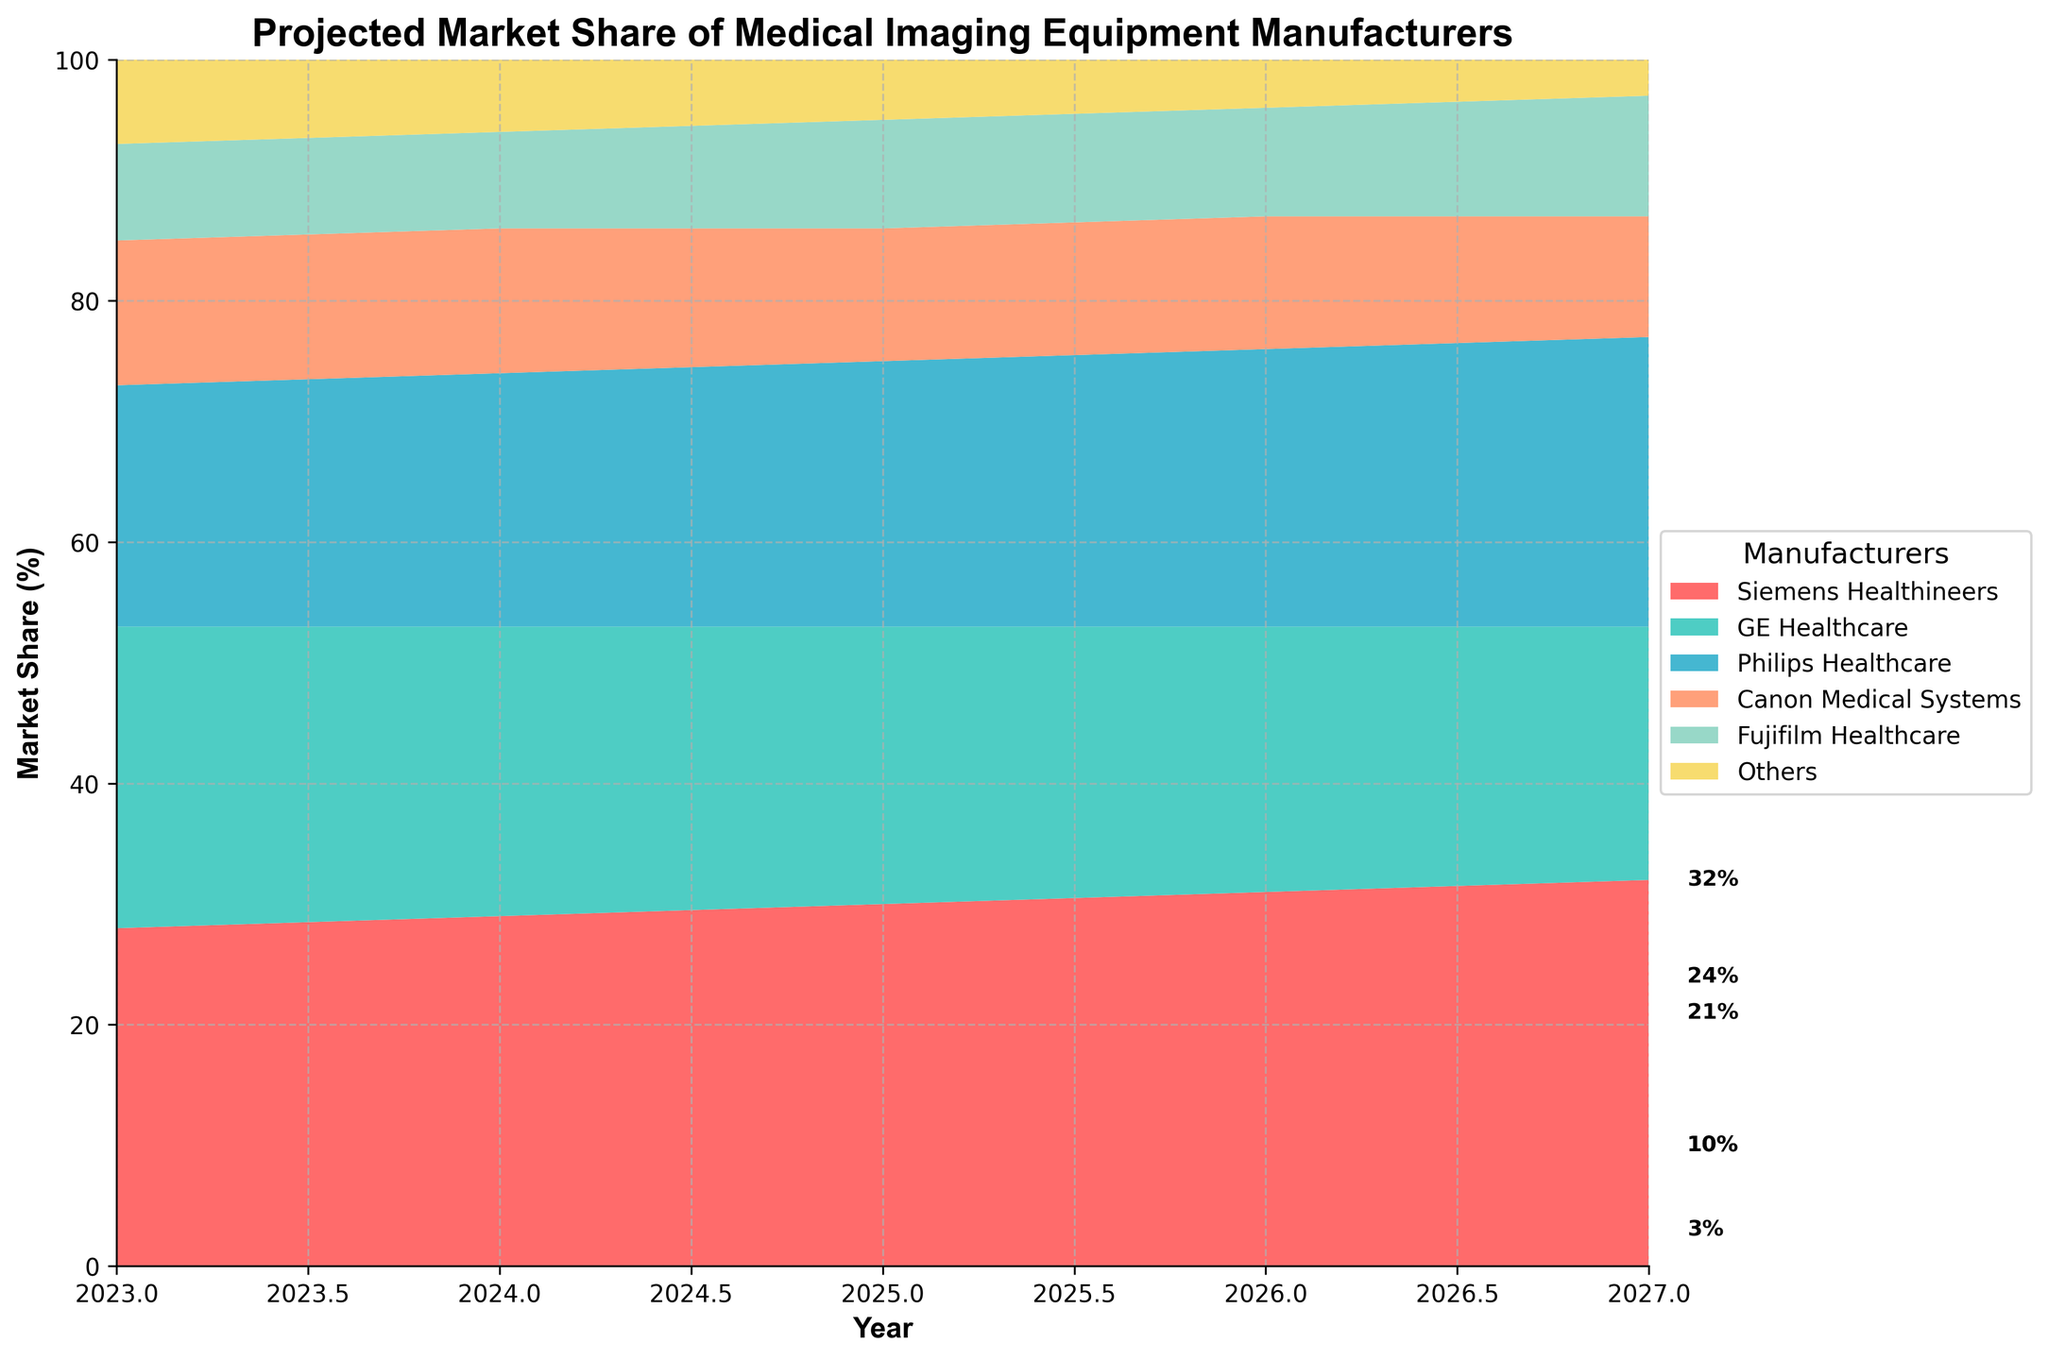What is the title of the chart? The title of the chart is at the top and it reads "Projected Market Share of Medical Imaging Equipment Manufacturers"
Answer: Projected Market Share of Medical Imaging Equipment Manufacturers Which company has the highest projected market share in 2027? Look at the stack at the topmost color by the end of the chart in 2027, which represents Siemens Healthineers. The chart indicates its market share is the highest.
Answer: Siemens Healthineers What is the range of years covered in the chart? The x-axis of the chart provides the range of years, starting from 2023 to 2027.
Answer: 2023 to 2027 How does the market share of Fujifilm Healthcare change from 2023 to 2027? The stack plot shows Fujifilm Healthcare's market share starting at 8% in 2023 and increasing to 10% in 2027.
Answer: Increases from 8% to 10% Comparing 2025 and 2027, which company's market share drops the most? Check the differences between these years across all companies. GE Healthcare's market share drops from 23% in 2025 to 21% in 2027, which is the largest drop of 2%.
Answer: GE Healthcare What is the cumulative market share of Siemens Healthineers and Philips Healthcare in 2026? Siemens Healthineers has a market share of 31% and Philips Healthcare has 23% in 2026. Add these percentages together for the cumulative share.
Answer: 54% Which company has a consistently increasing market share over the years? Observe the trend lines of the stacks for each company. Siemens Healthineers consistently increases from 28% in 2023 to 32% in 2027.
Answer: Siemens Healthineers By how many percentage points does Canon Medical Systems' market share decrease from 2023 to 2027? In 2023, Canon has 12%, and in 2027, it has 10%. Subtract the latter from the former to find the decrease.
Answer: 2 percentage points What is the projected market share of 'Others' in 2024? Locate the stack representing 'Others' at the year 2024 on the x-axis; it shows a market share of 6%.
Answer: 6% Is there any company projected to have the same market share in both 2023 and 2024? Look for identical figures in two consecutive years. Canon Medical Systems has a market share of 12% in both 2023 and 2024.
Answer: Yes, Canon Medical Systems 